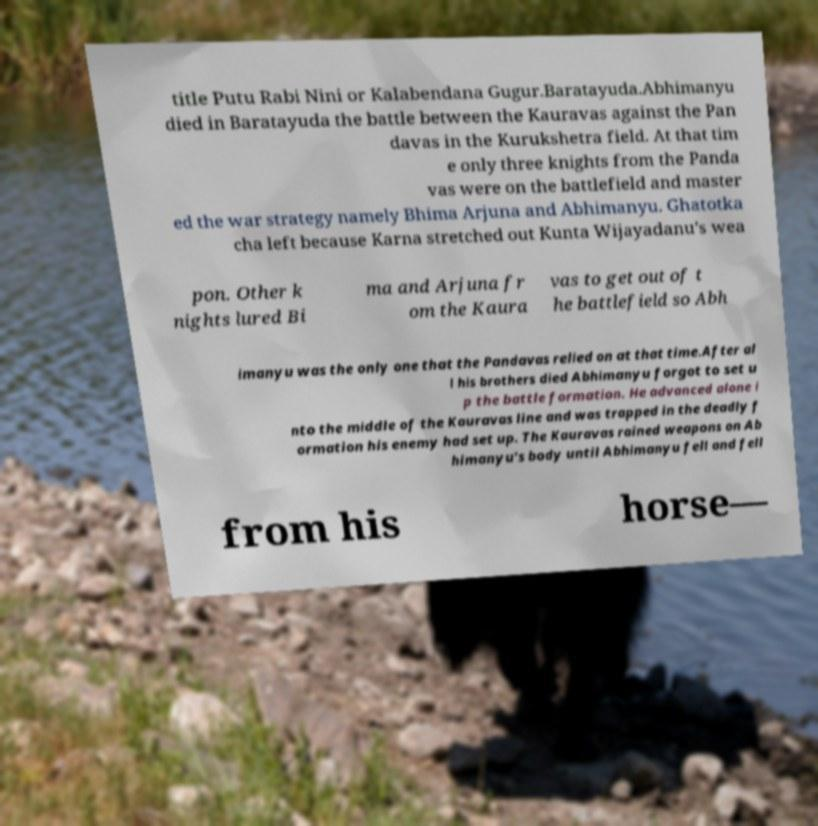Could you assist in decoding the text presented in this image and type it out clearly? title Putu Rabi Nini or Kalabendana Gugur.Baratayuda.Abhimanyu died in Baratayuda the battle between the Kauravas against the Pan davas in the Kurukshetra field. At that tim e only three knights from the Panda vas were on the battlefield and master ed the war strategy namely Bhima Arjuna and Abhimanyu. Ghatotka cha left because Karna stretched out Kunta Wijayadanu's wea pon. Other k nights lured Bi ma and Arjuna fr om the Kaura vas to get out of t he battlefield so Abh imanyu was the only one that the Pandavas relied on at that time.After al l his brothers died Abhimanyu forgot to set u p the battle formation. He advanced alone i nto the middle of the Kauravas line and was trapped in the deadly f ormation his enemy had set up. The Kauravas rained weapons on Ab himanyu's body until Abhimanyu fell and fell from his horse— 